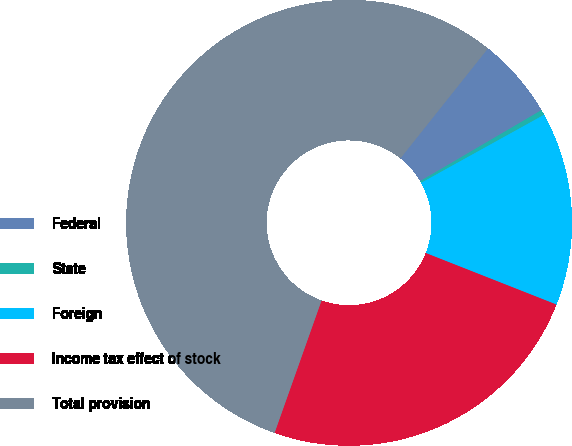Convert chart. <chart><loc_0><loc_0><loc_500><loc_500><pie_chart><fcel>Federal<fcel>State<fcel>Foreign<fcel>Income tax effect of stock<fcel>Total provision<nl><fcel>5.87%<fcel>0.38%<fcel>14.03%<fcel>24.45%<fcel>55.28%<nl></chart> 